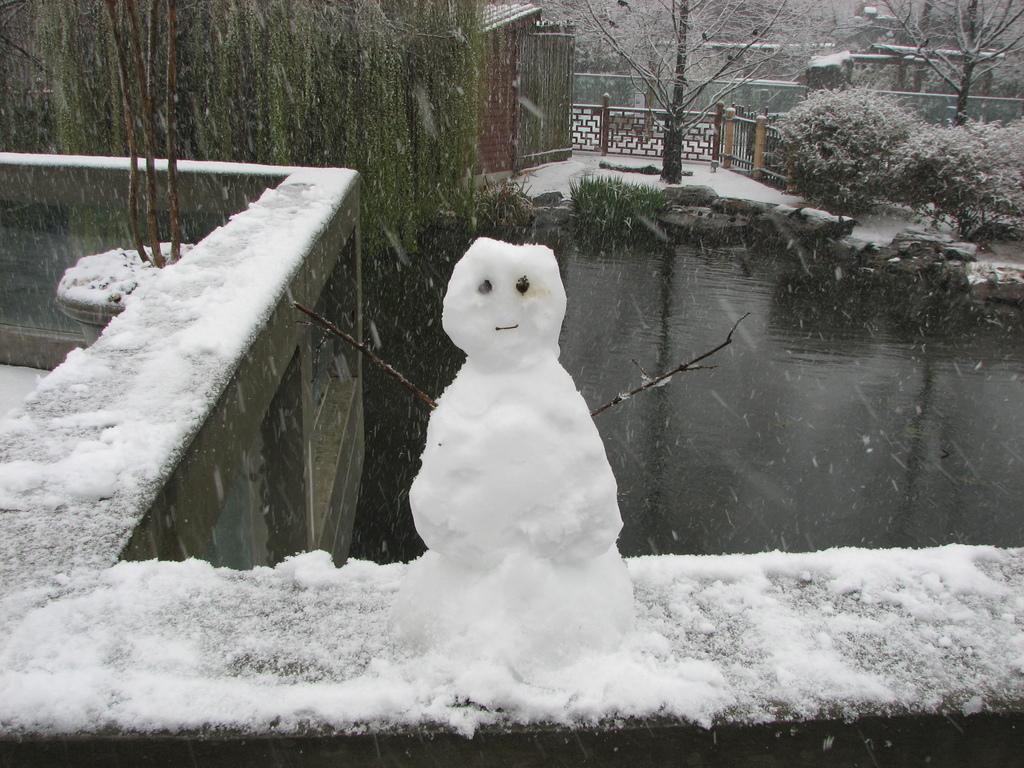Can you describe this image briefly? In this picture I can see a snowman, there is snow, fence, there is a house, there are rocks, trees and there is water. 